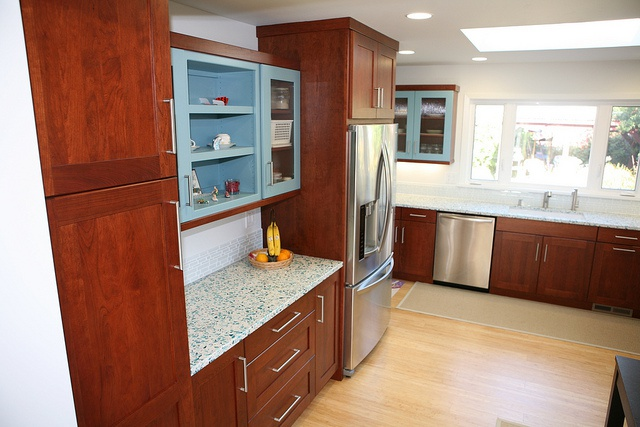Describe the objects in this image and their specific colors. I can see refrigerator in lightgray, darkgray, beige, gray, and tan tones, dining table in lightgray, gray, black, and maroon tones, bowl in lightgray, orange, gray, and tan tones, sink in lightgray and darkgray tones, and banana in lightgray, orange, olive, and gold tones in this image. 